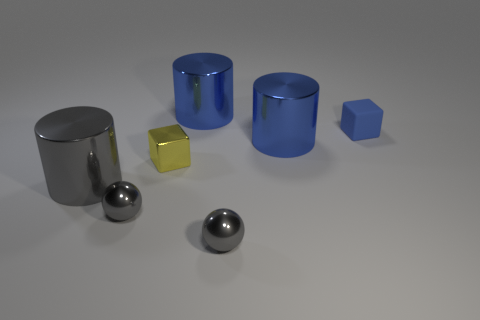Subtract all large gray cylinders. How many cylinders are left? 2 Subtract all blue blocks. How many blocks are left? 1 Add 3 big gray cylinders. How many objects exist? 10 Subtract all blocks. How many objects are left? 5 Subtract all blue cylinders. How many green blocks are left? 0 Subtract all small blocks. Subtract all big yellow metal cylinders. How many objects are left? 5 Add 2 tiny shiny objects. How many tiny shiny objects are left? 5 Add 7 tiny blue blocks. How many tiny blue blocks exist? 8 Subtract 1 yellow blocks. How many objects are left? 6 Subtract 2 cylinders. How many cylinders are left? 1 